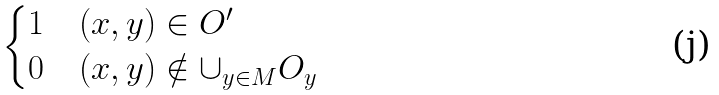Convert formula to latex. <formula><loc_0><loc_0><loc_500><loc_500>\begin{cases} 1 & ( x , y ) \in O ^ { \prime } \\ 0 & ( x , y ) \notin \cup _ { y \in M } O _ { y } \end{cases}</formula> 